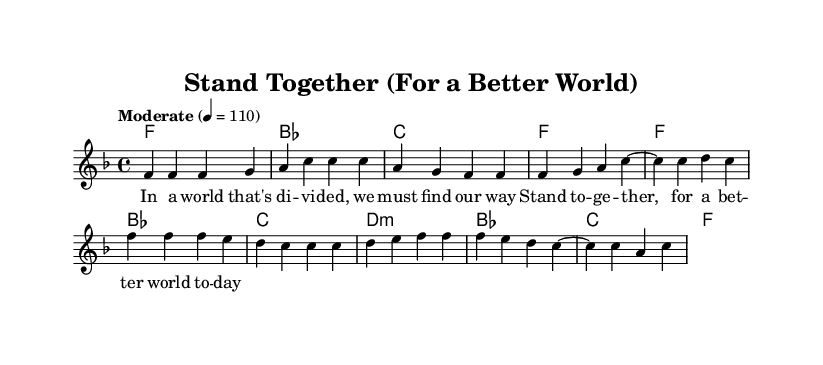What is the key signature of this music? The key signature is indicated by a single flat (B♭) on the staff, which is standard for the key of F major.
Answer: F major What is the time signature of the piece? The time signature appears at the beginning and indicates that there are four beats in each measure, or bar, which is shown as 4/4.
Answer: 4/4 What is the tempo marking provided? The tempo marking in the score is given as "Moderate," followed by a metronome marking of 110 beats per minute, indicating the speed of the music.
Answer: Moderate 4 = 110 How many measures does the verse consist of? By counting the measures labeled in the melody section, the verse has a total of six measures, prominently featuring a simple melodic pattern.
Answer: 6 Identify the first chord in the harmony section. The first chord listed in the harmonic progression is indicated at the very beginning of the harmonies section, which is F major.
Answer: F What are the main themes reflected in the lyrics? Analyzing the provided lyrics, the themes revolve around unity and social change, as mentioned in phrases contextualizing collective action for a better world.
Answer: Unity and social change What musical genre does this piece represent? The structure, instrumentation, and lyrical themes align with characteristics typical of Rhythm and Blues (R&B), highlighting emotional and social dimensions.
Answer: Rhythm and Blues 